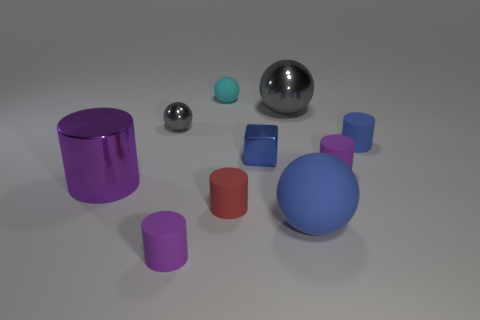Does the block have the same material as the cylinder to the left of the small gray thing?
Keep it short and to the point. Yes. How many large shiny objects are behind the big metallic object that is on the left side of the small cylinder that is in front of the blue rubber sphere?
Offer a terse response. 1. Are there fewer large purple metal cylinders that are on the right side of the big purple shiny cylinder than blue rubber things that are in front of the small block?
Provide a short and direct response. Yes. How many other objects are there of the same material as the large gray object?
Ensure brevity in your answer.  3. There is a cube that is the same size as the blue cylinder; what is it made of?
Your answer should be compact. Metal. What number of green objects are big matte spheres or tiny metallic balls?
Keep it short and to the point. 0. The small cylinder that is both behind the big blue ball and to the left of the large blue rubber ball is what color?
Your response must be concise. Red. Do the tiny purple cylinder that is on the left side of the large gray metal ball and the large sphere that is behind the blue cube have the same material?
Give a very brief answer. No. Is the number of small purple cylinders to the right of the red object greater than the number of tiny cyan objects to the left of the large purple shiny cylinder?
Make the answer very short. Yes. The gray thing that is the same size as the blue sphere is what shape?
Your response must be concise. Sphere. 